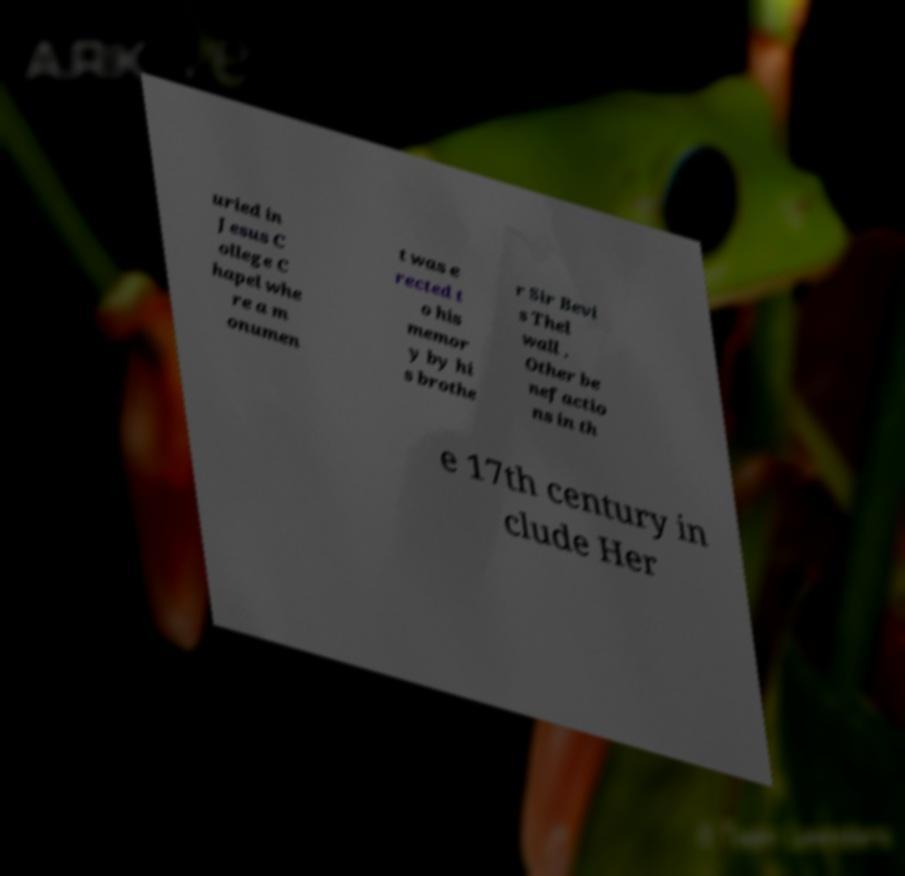For documentation purposes, I need the text within this image transcribed. Could you provide that? uried in Jesus C ollege C hapel whe re a m onumen t was e rected t o his memor y by hi s brothe r Sir Bevi s Thel wall . Other be nefactio ns in th e 17th century in clude Her 